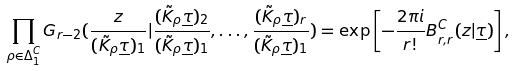Convert formula to latex. <formula><loc_0><loc_0><loc_500><loc_500>\prod _ { \rho \in \Delta _ { 1 } ^ { C } } G _ { r - 2 } ( \frac { z } { ( \tilde { K } _ { \rho } \underline { \tau } ) _ { 1 } } | \frac { ( \tilde { K } _ { \rho } \underline { \tau } ) _ { 2 } } { ( \tilde { K } _ { \rho } \underline { \tau } ) _ { 1 } } , \dots , \frac { ( \tilde { K } _ { \rho } \underline { \tau } ) _ { r } } { ( \tilde { K } _ { \rho } \underline { \tau } ) _ { 1 } } ) = \exp \left [ - \frac { 2 \pi i } { r ! } B _ { r , r } ^ { C } ( z | \underline { \tau } ) \right ] ,</formula> 